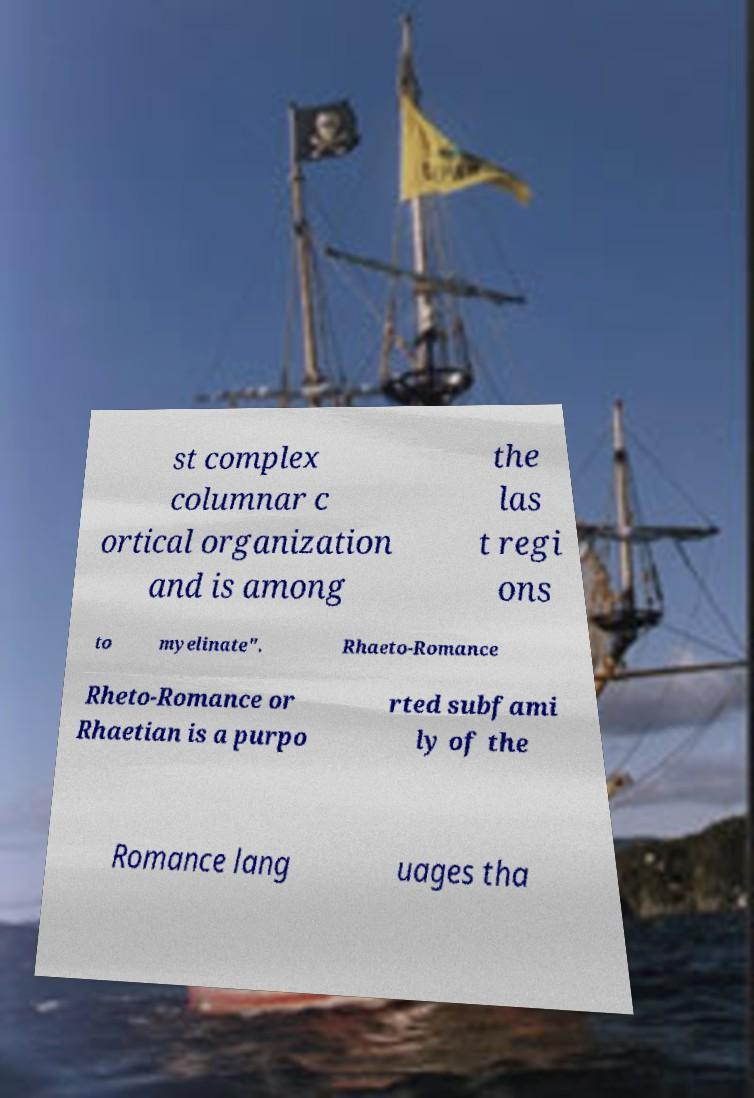Can you read and provide the text displayed in the image?This photo seems to have some interesting text. Can you extract and type it out for me? st complex columnar c ortical organization and is among the las t regi ons to myelinate". Rhaeto-Romance Rheto-Romance or Rhaetian is a purpo rted subfami ly of the Romance lang uages tha 